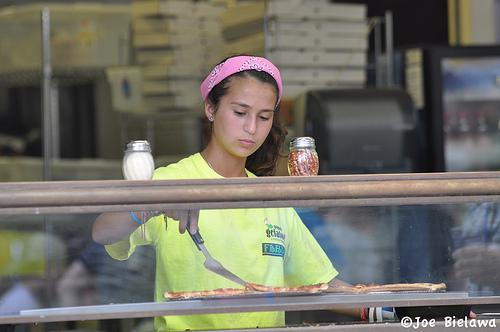Question: where is the girl working?
Choices:
A. A restaurant.
B. In a library.
C. In an office.
D. On the street.
Answer with the letter. Answer: A Question: who is serving pizza?
Choices:
A. The chef.
B. A mother.
C. A girl.
D. A stewardess.
Answer with the letter. Answer: C Question: what is behind the girl?
Choices:
A. Pizza boxes.
B. A fireplace.
C. Trees.
D. A fence.
Answer with the letter. Answer: A Question: what food is being served?
Choices:
A. Hot dogs.
B. Spaghetti.
C. Pizza.
D. Tacos.
Answer with the letter. Answer: C 